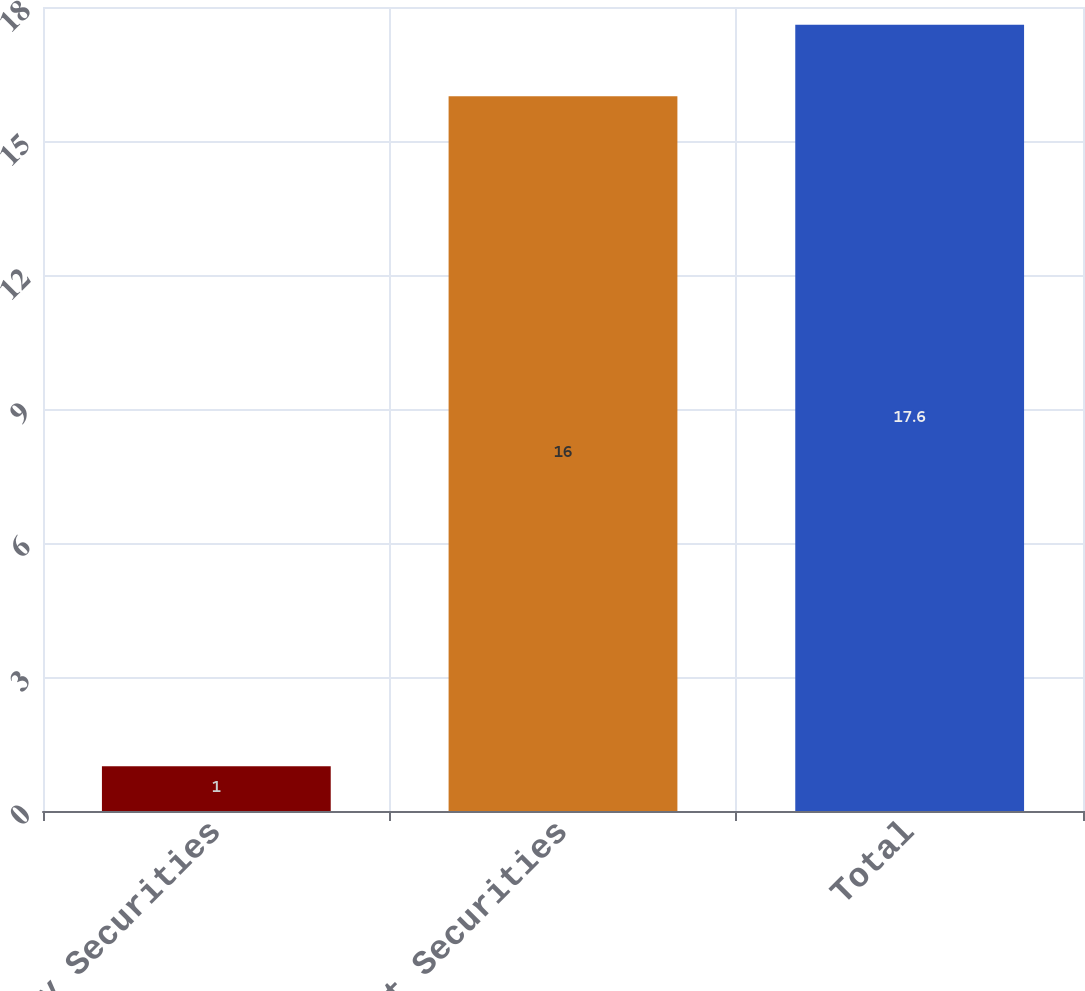Convert chart to OTSL. <chart><loc_0><loc_0><loc_500><loc_500><bar_chart><fcel>Equity Securities<fcel>Debt Securities<fcel>Total<nl><fcel>1<fcel>16<fcel>17.6<nl></chart> 